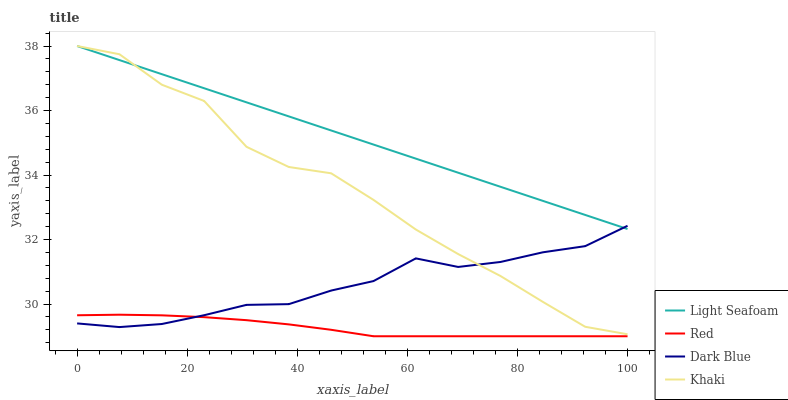Does Khaki have the minimum area under the curve?
Answer yes or no. No. Does Khaki have the maximum area under the curve?
Answer yes or no. No. Is Khaki the smoothest?
Answer yes or no. No. Is Light Seafoam the roughest?
Answer yes or no. No. Does Khaki have the lowest value?
Answer yes or no. No. Does Red have the highest value?
Answer yes or no. No. Is Red less than Khaki?
Answer yes or no. Yes. Is Khaki greater than Red?
Answer yes or no. Yes. Does Red intersect Khaki?
Answer yes or no. No. 